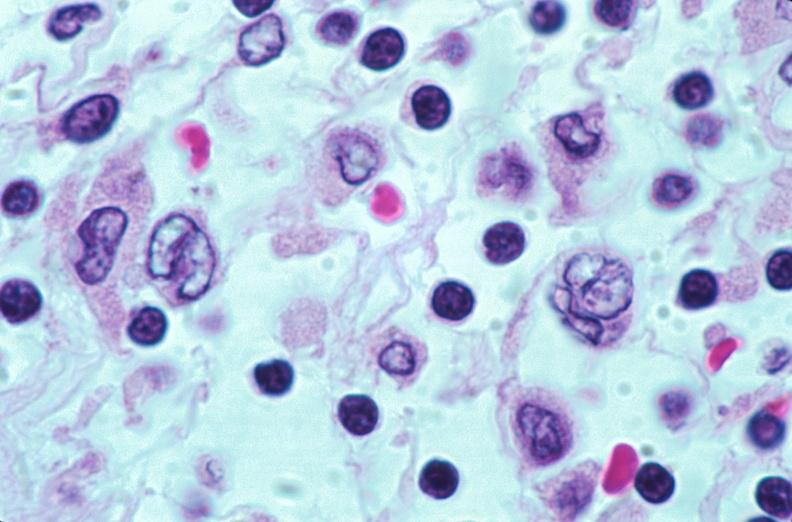what does this image show?
Answer the question using a single word or phrase. Lymph nodes 